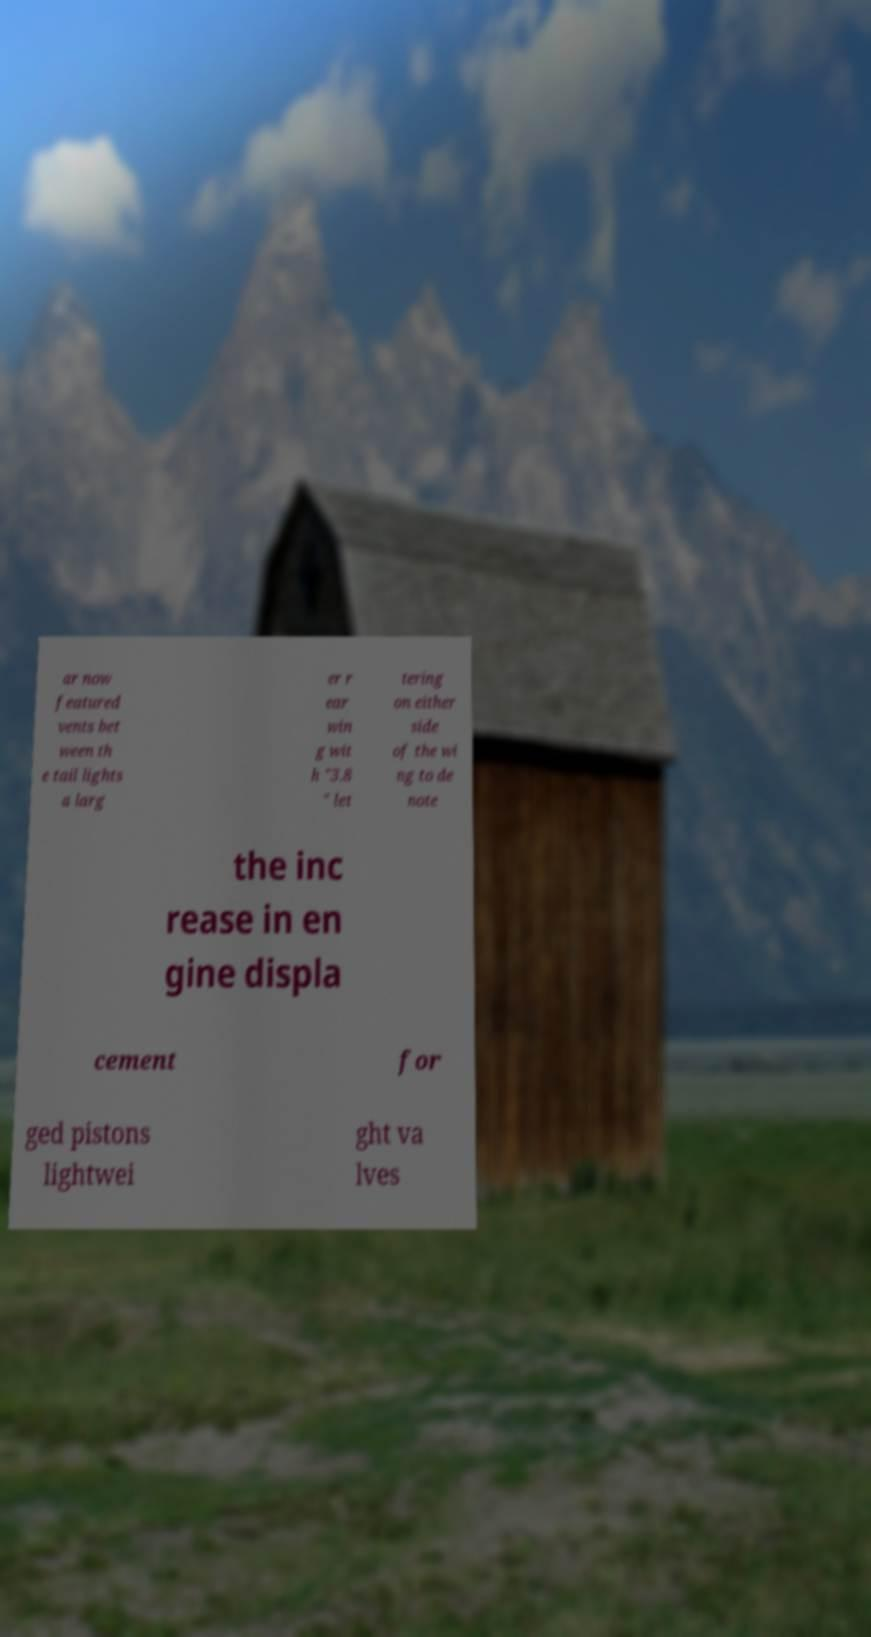Can you read and provide the text displayed in the image?This photo seems to have some interesting text. Can you extract and type it out for me? ar now featured vents bet ween th e tail lights a larg er r ear win g wit h "3.8 " let tering on either side of the wi ng to de note the inc rease in en gine displa cement for ged pistons lightwei ght va lves 